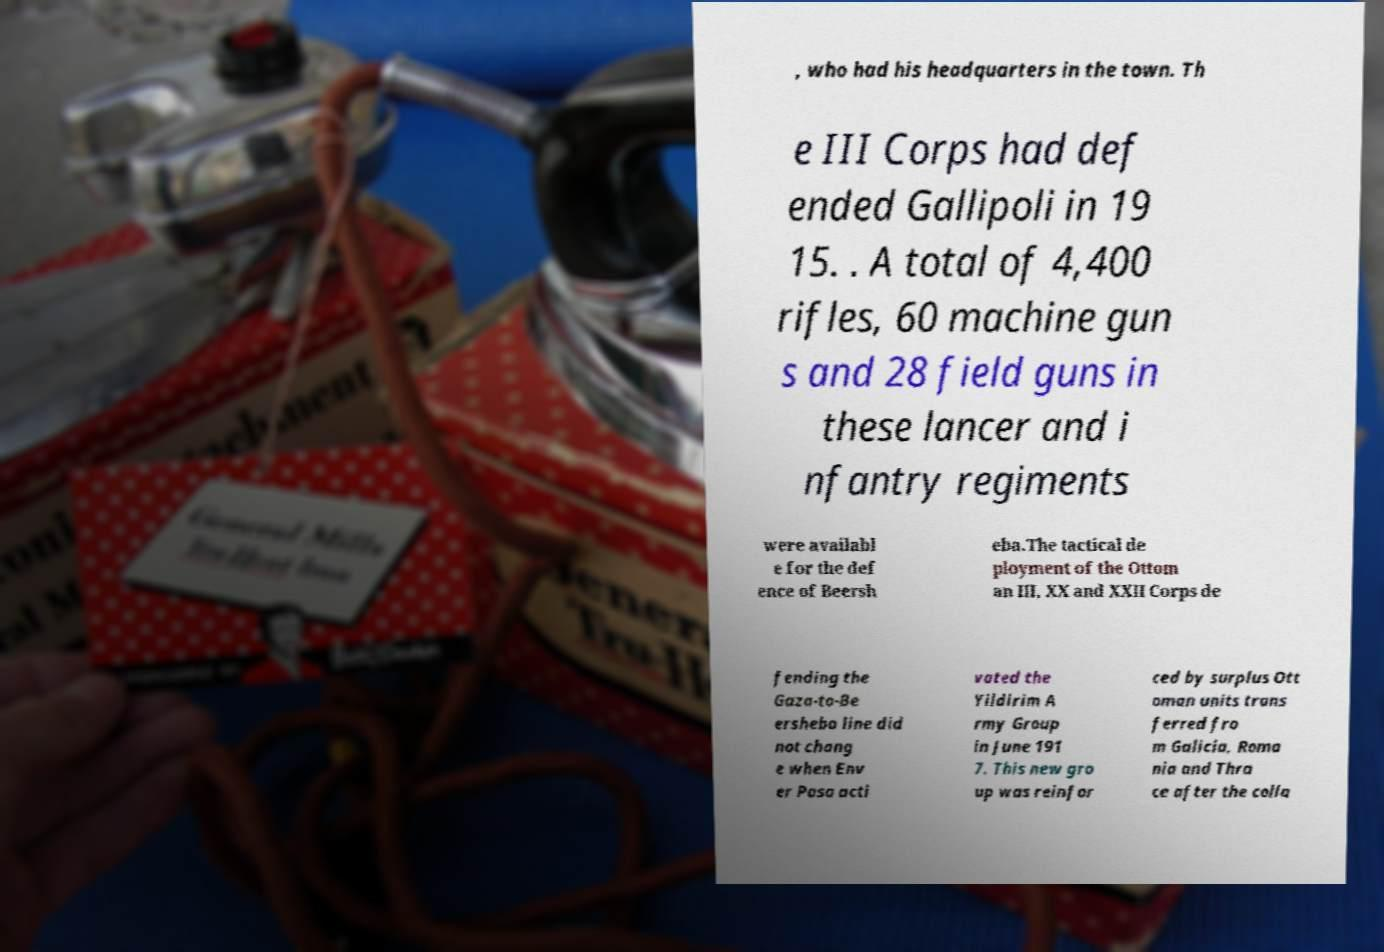Can you read and provide the text displayed in the image?This photo seems to have some interesting text. Can you extract and type it out for me? , who had his headquarters in the town. Th e III Corps had def ended Gallipoli in 19 15. . A total of 4,400 rifles, 60 machine gun s and 28 field guns in these lancer and i nfantry regiments were availabl e for the def ence of Beersh eba.The tactical de ployment of the Ottom an III, XX and XXII Corps de fending the Gaza-to-Be ersheba line did not chang e when Env er Pasa acti vated the Yildirim A rmy Group in June 191 7. This new gro up was reinfor ced by surplus Ott oman units trans ferred fro m Galicia, Roma nia and Thra ce after the colla 